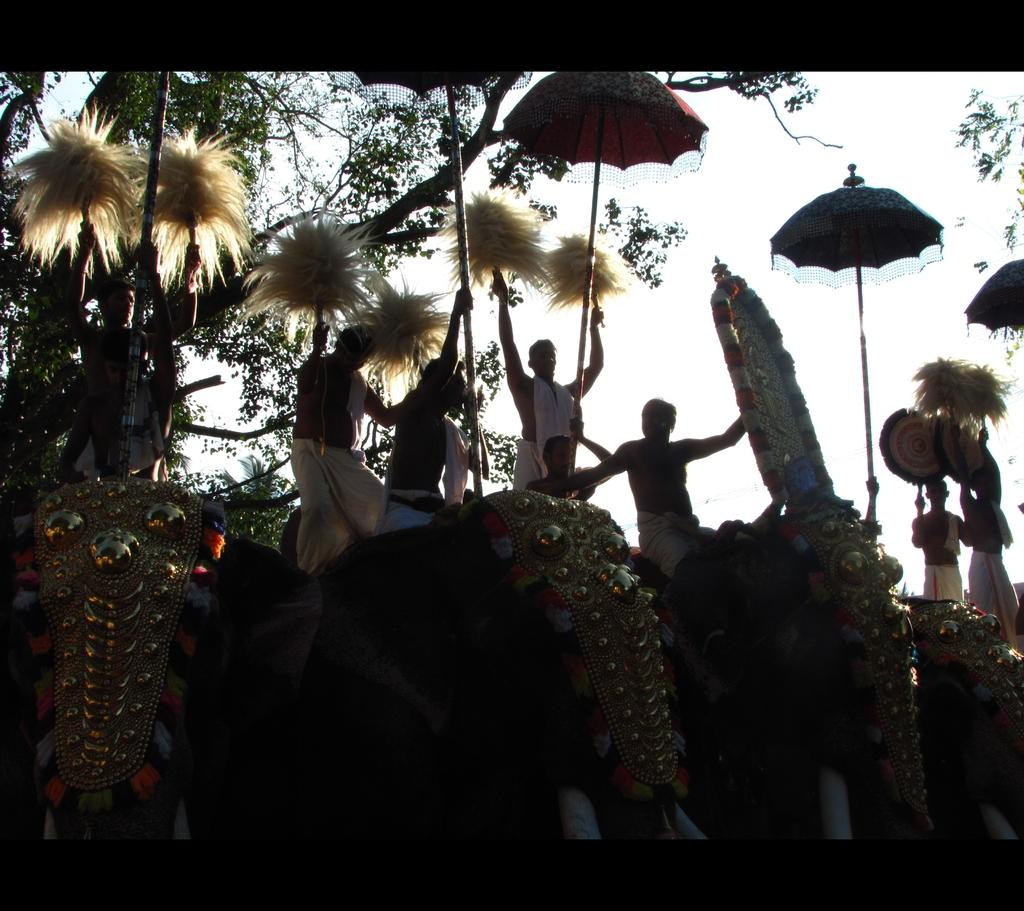What animals are in the image? There are elephants in the image. What are the people on the elephants doing? The people are on the elephants. What are the people holding? The people are holding things. What type of shelter is visible in the image? Umbrellas are present in the image. What type of vegetation can be seen in the image? There are trees and plants in the image. What type of treatment is the dad receiving from the chickens in the image? There are no chickens or dad present in the image, so no such treatment can be observed. 